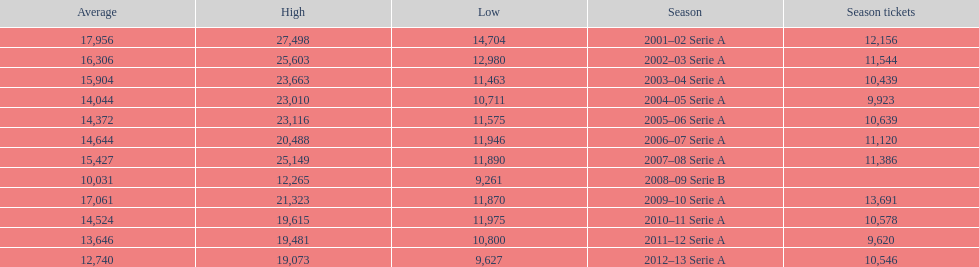How many seasons had average attendance of at least 15,000 at the stadio ennio tardini? 5. 